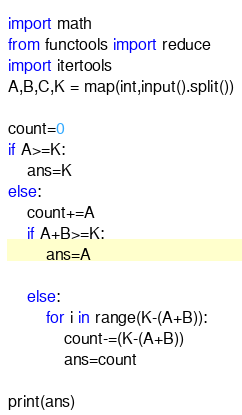Convert code to text. <code><loc_0><loc_0><loc_500><loc_500><_Python_>import math
from functools import reduce
import itertools
A,B,C,K = map(int,input().split())

count=0
if A>=K:
    ans=K
else:
    count+=A
    if A+B>=K:
        ans=A

    else:
        for i in range(K-(A+B)):
            count-=(K-(A+B))
            ans=count

print(ans)
</code> 